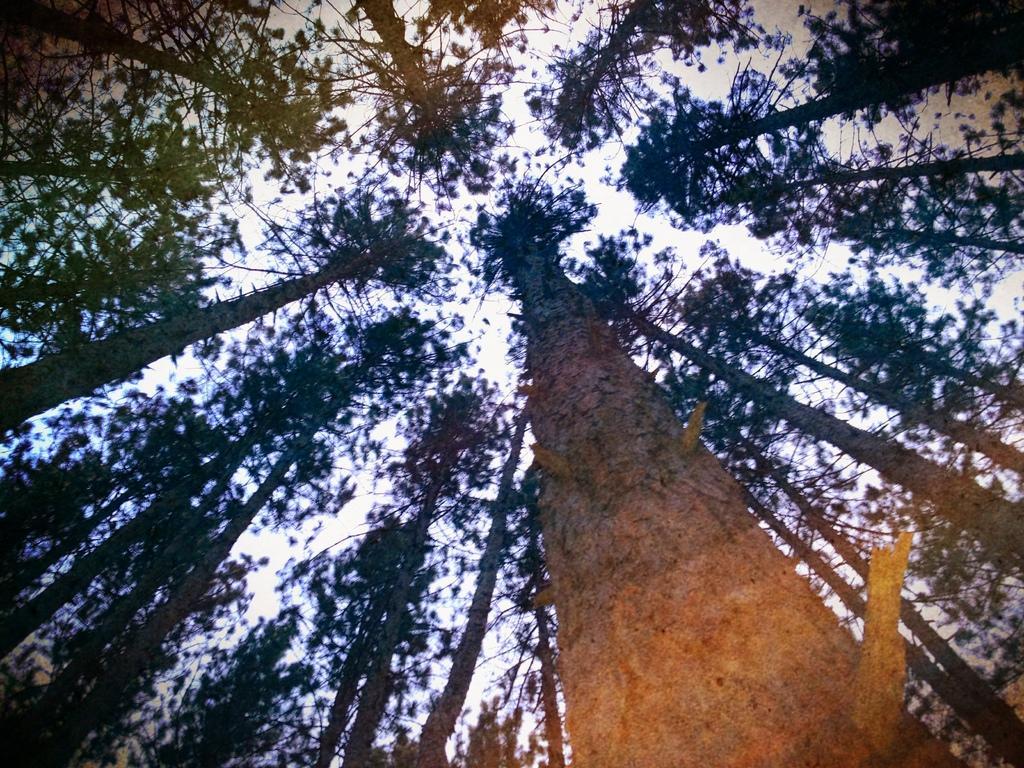Can you describe this image briefly? In this picture I can see some trees. 